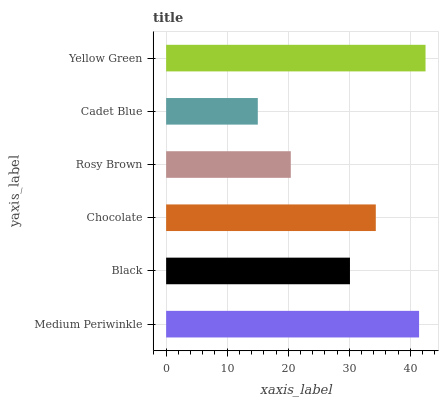Is Cadet Blue the minimum?
Answer yes or no. Yes. Is Yellow Green the maximum?
Answer yes or no. Yes. Is Black the minimum?
Answer yes or no. No. Is Black the maximum?
Answer yes or no. No. Is Medium Periwinkle greater than Black?
Answer yes or no. Yes. Is Black less than Medium Periwinkle?
Answer yes or no. Yes. Is Black greater than Medium Periwinkle?
Answer yes or no. No. Is Medium Periwinkle less than Black?
Answer yes or no. No. Is Chocolate the high median?
Answer yes or no. Yes. Is Black the low median?
Answer yes or no. Yes. Is Yellow Green the high median?
Answer yes or no. No. Is Medium Periwinkle the low median?
Answer yes or no. No. 